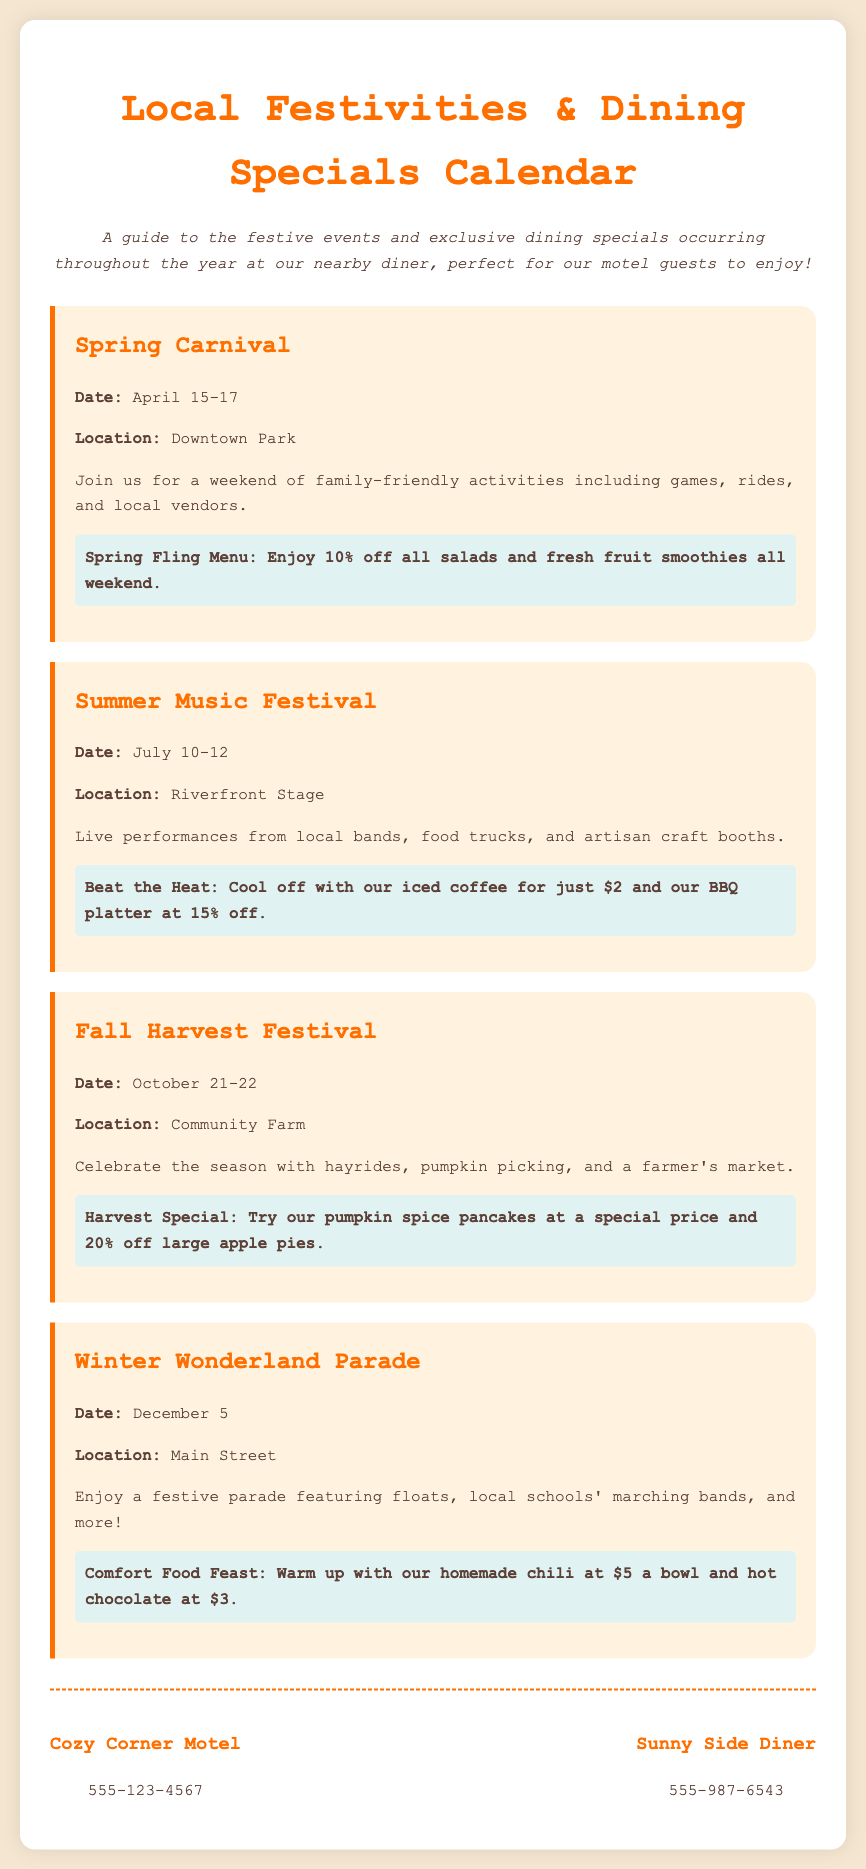What is the date of the Spring Carnival? The Spring Carnival occurs from April 15 to April 17.
Answer: April 15-17 Where is the Summer Music Festival held? The Summer Music Festival takes place at the Riverfront Stage.
Answer: Riverfront Stage What dining special is offered during the Fall Harvest Festival? The Fall Harvest Festival features a special price for pumpkin spice pancakes and 20% off large apple pies.
Answer: Pumpkin spice pancakes and 20% off large apple pies What is the contact number for the Cozy Corner Motel? The document lists the contact number for the Cozy Corner Motel as 555-123-4567.
Answer: 555-123-4567 How many days does the Winter Wonderland Parade last? The Winter Wonderland Parade is held for one day on December 5.
Answer: One day What activities are included in the Spring Carnival? The Spring Carnival includes games, rides, and local vendors as activities for families.
Answer: Games, rides, and local vendors Which event has the most extensive duration within the document? The Spring Carnival lasts for three days, which is longer than the other events listed.
Answer: Three days What is the theme of the Winter Wonderland Parade? The Winter Wonderland Parade focuses on festive celebrations with floats and marching bands.
Answer: Festive celebrations 